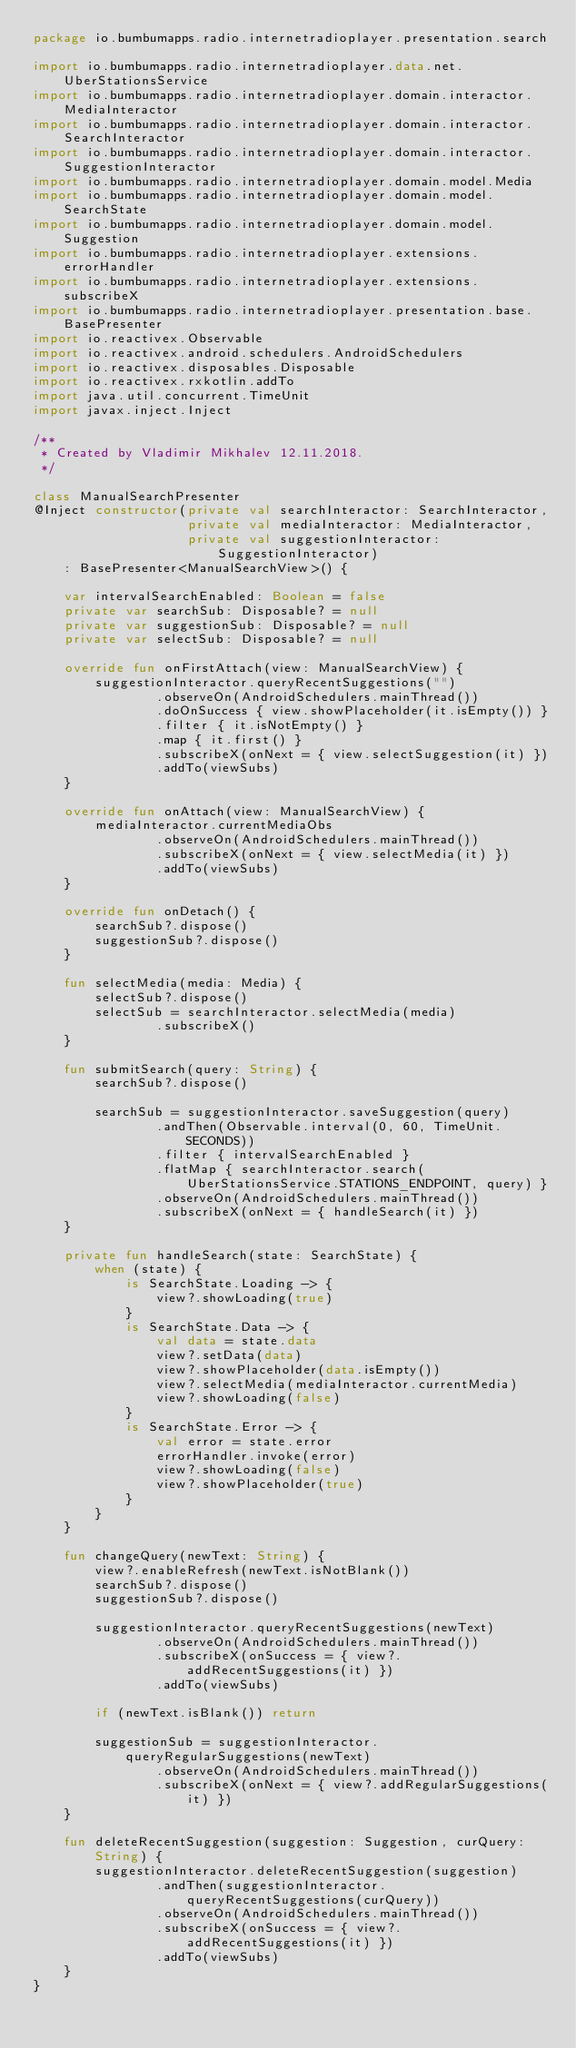<code> <loc_0><loc_0><loc_500><loc_500><_Kotlin_>package io.bumbumapps.radio.internetradioplayer.presentation.search

import io.bumbumapps.radio.internetradioplayer.data.net.UberStationsService
import io.bumbumapps.radio.internetradioplayer.domain.interactor.MediaInteractor
import io.bumbumapps.radio.internetradioplayer.domain.interactor.SearchInteractor
import io.bumbumapps.radio.internetradioplayer.domain.interactor.SuggestionInteractor
import io.bumbumapps.radio.internetradioplayer.domain.model.Media
import io.bumbumapps.radio.internetradioplayer.domain.model.SearchState
import io.bumbumapps.radio.internetradioplayer.domain.model.Suggestion
import io.bumbumapps.radio.internetradioplayer.extensions.errorHandler
import io.bumbumapps.radio.internetradioplayer.extensions.subscribeX
import io.bumbumapps.radio.internetradioplayer.presentation.base.BasePresenter
import io.reactivex.Observable
import io.reactivex.android.schedulers.AndroidSchedulers
import io.reactivex.disposables.Disposable
import io.reactivex.rxkotlin.addTo
import java.util.concurrent.TimeUnit
import javax.inject.Inject

/**
 * Created by Vladimir Mikhalev 12.11.2018.
 */

class ManualSearchPresenter
@Inject constructor(private val searchInteractor: SearchInteractor,
                    private val mediaInteractor: MediaInteractor,
                    private val suggestionInteractor: SuggestionInteractor)
    : BasePresenter<ManualSearchView>() {

    var intervalSearchEnabled: Boolean = false
    private var searchSub: Disposable? = null
    private var suggestionSub: Disposable? = null
    private var selectSub: Disposable? = null

    override fun onFirstAttach(view: ManualSearchView) {
        suggestionInteractor.queryRecentSuggestions("")
                .observeOn(AndroidSchedulers.mainThread())
                .doOnSuccess { view.showPlaceholder(it.isEmpty()) }
                .filter { it.isNotEmpty() }
                .map { it.first() }
                .subscribeX(onNext = { view.selectSuggestion(it) })
                .addTo(viewSubs)
    }

    override fun onAttach(view: ManualSearchView) {
        mediaInteractor.currentMediaObs
                .observeOn(AndroidSchedulers.mainThread())
                .subscribeX(onNext = { view.selectMedia(it) })
                .addTo(viewSubs)
    }

    override fun onDetach() {
        searchSub?.dispose()
        suggestionSub?.dispose()
    }

    fun selectMedia(media: Media) {
        selectSub?.dispose()
        selectSub = searchInteractor.selectMedia(media)
                .subscribeX()
    }

    fun submitSearch(query: String) {
        searchSub?.dispose()

        searchSub = suggestionInteractor.saveSuggestion(query)
                .andThen(Observable.interval(0, 60, TimeUnit.SECONDS))
                .filter { intervalSearchEnabled }
                .flatMap { searchInteractor.search(UberStationsService.STATIONS_ENDPOINT, query) }
                .observeOn(AndroidSchedulers.mainThread())
                .subscribeX(onNext = { handleSearch(it) })
    }

    private fun handleSearch(state: SearchState) {
        when (state) {
            is SearchState.Loading -> {
                view?.showLoading(true)
            }
            is SearchState.Data -> {
                val data = state.data
                view?.setData(data)
                view?.showPlaceholder(data.isEmpty())
                view?.selectMedia(mediaInteractor.currentMedia)
                view?.showLoading(false)
            }
            is SearchState.Error -> {
                val error = state.error
                errorHandler.invoke(error)
                view?.showLoading(false)
                view?.showPlaceholder(true)
            }
        }
    }

    fun changeQuery(newText: String) {
        view?.enableRefresh(newText.isNotBlank())
        searchSub?.dispose()
        suggestionSub?.dispose()

        suggestionInteractor.queryRecentSuggestions(newText)
                .observeOn(AndroidSchedulers.mainThread())
                .subscribeX(onSuccess = { view?.addRecentSuggestions(it) })
                .addTo(viewSubs)

        if (newText.isBlank()) return

        suggestionSub = suggestionInteractor.queryRegularSuggestions(newText)
                .observeOn(AndroidSchedulers.mainThread())
                .subscribeX(onNext = { view?.addRegularSuggestions(it) })
    }

    fun deleteRecentSuggestion(suggestion: Suggestion, curQuery: String) {
        suggestionInteractor.deleteRecentSuggestion(suggestion)
                .andThen(suggestionInteractor.queryRecentSuggestions(curQuery))
                .observeOn(AndroidSchedulers.mainThread())
                .subscribeX(onSuccess = { view?.addRecentSuggestions(it) })
                .addTo(viewSubs)
    }
}
</code> 